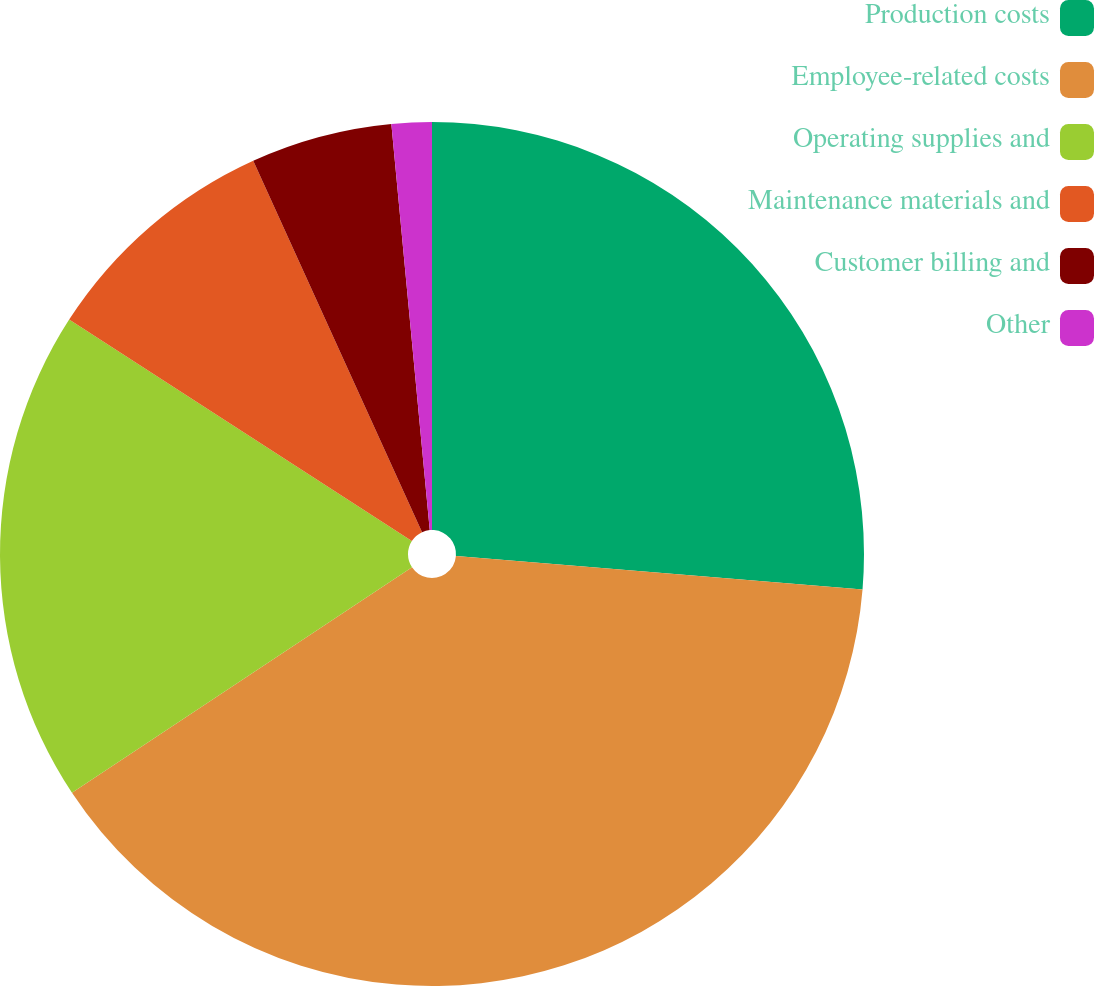Convert chart to OTSL. <chart><loc_0><loc_0><loc_500><loc_500><pie_chart><fcel>Production costs<fcel>Employee-related costs<fcel>Operating supplies and<fcel>Maintenance materials and<fcel>Customer billing and<fcel>Other<nl><fcel>26.31%<fcel>39.37%<fcel>18.45%<fcel>9.08%<fcel>5.29%<fcel>1.5%<nl></chart> 